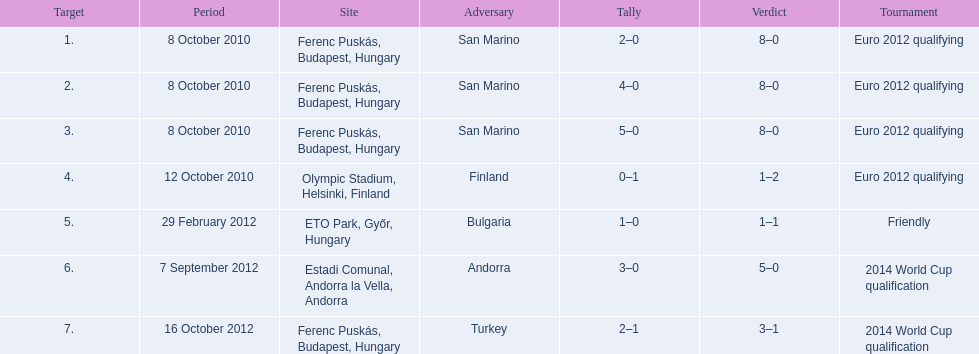When did ádám szalai make his first international goal? 8 October 2010. 